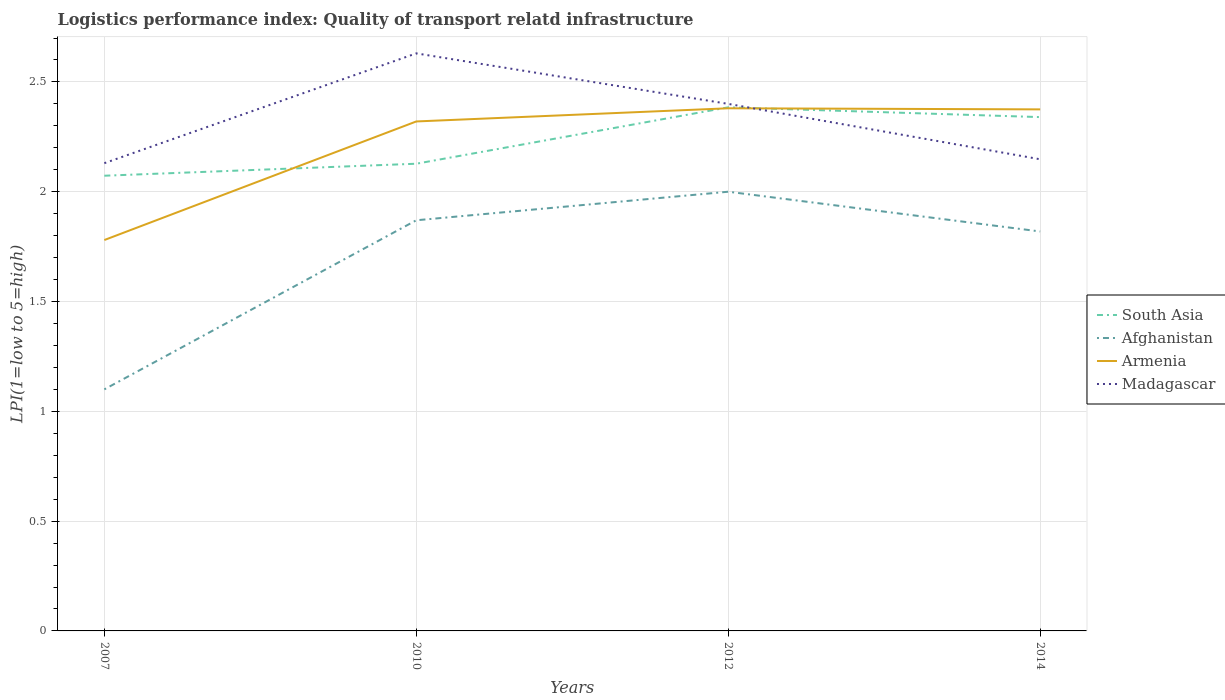Across all years, what is the maximum logistics performance index in Madagascar?
Give a very brief answer. 2.13. What is the total logistics performance index in Afghanistan in the graph?
Offer a terse response. -0.72. What is the difference between the highest and the second highest logistics performance index in Armenia?
Give a very brief answer. 0.6. How many lines are there?
Provide a short and direct response. 4. How many years are there in the graph?
Provide a short and direct response. 4. What is the difference between two consecutive major ticks on the Y-axis?
Your answer should be compact. 0.5. Are the values on the major ticks of Y-axis written in scientific E-notation?
Your answer should be compact. No. Does the graph contain any zero values?
Ensure brevity in your answer.  No. How many legend labels are there?
Give a very brief answer. 4. How are the legend labels stacked?
Offer a terse response. Vertical. What is the title of the graph?
Give a very brief answer. Logistics performance index: Quality of transport relatd infrastructure. What is the label or title of the X-axis?
Ensure brevity in your answer.  Years. What is the label or title of the Y-axis?
Keep it short and to the point. LPI(1=low to 5=high). What is the LPI(1=low to 5=high) of South Asia in 2007?
Give a very brief answer. 2.07. What is the LPI(1=low to 5=high) of Afghanistan in 2007?
Provide a short and direct response. 1.1. What is the LPI(1=low to 5=high) in Armenia in 2007?
Offer a terse response. 1.78. What is the LPI(1=low to 5=high) in Madagascar in 2007?
Your answer should be very brief. 2.13. What is the LPI(1=low to 5=high) of South Asia in 2010?
Offer a very short reply. 2.13. What is the LPI(1=low to 5=high) in Afghanistan in 2010?
Make the answer very short. 1.87. What is the LPI(1=low to 5=high) in Armenia in 2010?
Your answer should be very brief. 2.32. What is the LPI(1=low to 5=high) in Madagascar in 2010?
Provide a succinct answer. 2.63. What is the LPI(1=low to 5=high) of South Asia in 2012?
Your answer should be compact. 2.38. What is the LPI(1=low to 5=high) in Armenia in 2012?
Your answer should be very brief. 2.38. What is the LPI(1=low to 5=high) of Madagascar in 2012?
Provide a short and direct response. 2.4. What is the LPI(1=low to 5=high) of South Asia in 2014?
Your response must be concise. 2.34. What is the LPI(1=low to 5=high) in Afghanistan in 2014?
Your answer should be compact. 1.82. What is the LPI(1=low to 5=high) of Armenia in 2014?
Ensure brevity in your answer.  2.38. What is the LPI(1=low to 5=high) in Madagascar in 2014?
Offer a terse response. 2.15. Across all years, what is the maximum LPI(1=low to 5=high) of South Asia?
Provide a short and direct response. 2.38. Across all years, what is the maximum LPI(1=low to 5=high) of Afghanistan?
Your answer should be very brief. 2. Across all years, what is the maximum LPI(1=low to 5=high) of Armenia?
Your response must be concise. 2.38. Across all years, what is the maximum LPI(1=low to 5=high) of Madagascar?
Provide a short and direct response. 2.63. Across all years, what is the minimum LPI(1=low to 5=high) of South Asia?
Keep it short and to the point. 2.07. Across all years, what is the minimum LPI(1=low to 5=high) of Armenia?
Offer a very short reply. 1.78. Across all years, what is the minimum LPI(1=low to 5=high) of Madagascar?
Give a very brief answer. 2.13. What is the total LPI(1=low to 5=high) of South Asia in the graph?
Give a very brief answer. 8.92. What is the total LPI(1=low to 5=high) of Afghanistan in the graph?
Offer a terse response. 6.79. What is the total LPI(1=low to 5=high) in Armenia in the graph?
Your answer should be compact. 8.86. What is the total LPI(1=low to 5=high) in Madagascar in the graph?
Your answer should be very brief. 9.31. What is the difference between the LPI(1=low to 5=high) of South Asia in 2007 and that in 2010?
Offer a very short reply. -0.05. What is the difference between the LPI(1=low to 5=high) in Afghanistan in 2007 and that in 2010?
Offer a very short reply. -0.77. What is the difference between the LPI(1=low to 5=high) of Armenia in 2007 and that in 2010?
Your answer should be very brief. -0.54. What is the difference between the LPI(1=low to 5=high) of South Asia in 2007 and that in 2012?
Offer a terse response. -0.31. What is the difference between the LPI(1=low to 5=high) in Afghanistan in 2007 and that in 2012?
Offer a terse response. -0.9. What is the difference between the LPI(1=low to 5=high) in Armenia in 2007 and that in 2012?
Your response must be concise. -0.6. What is the difference between the LPI(1=low to 5=high) of Madagascar in 2007 and that in 2012?
Provide a short and direct response. -0.27. What is the difference between the LPI(1=low to 5=high) in South Asia in 2007 and that in 2014?
Your response must be concise. -0.27. What is the difference between the LPI(1=low to 5=high) of Afghanistan in 2007 and that in 2014?
Offer a terse response. -0.72. What is the difference between the LPI(1=low to 5=high) of Armenia in 2007 and that in 2014?
Your answer should be compact. -0.59. What is the difference between the LPI(1=low to 5=high) of Madagascar in 2007 and that in 2014?
Provide a succinct answer. -0.02. What is the difference between the LPI(1=low to 5=high) of South Asia in 2010 and that in 2012?
Provide a succinct answer. -0.26. What is the difference between the LPI(1=low to 5=high) in Afghanistan in 2010 and that in 2012?
Offer a very short reply. -0.13. What is the difference between the LPI(1=low to 5=high) in Armenia in 2010 and that in 2012?
Ensure brevity in your answer.  -0.06. What is the difference between the LPI(1=low to 5=high) in Madagascar in 2010 and that in 2012?
Your answer should be very brief. 0.23. What is the difference between the LPI(1=low to 5=high) of South Asia in 2010 and that in 2014?
Give a very brief answer. -0.21. What is the difference between the LPI(1=low to 5=high) in Afghanistan in 2010 and that in 2014?
Provide a short and direct response. 0.05. What is the difference between the LPI(1=low to 5=high) in Armenia in 2010 and that in 2014?
Your answer should be compact. -0.06. What is the difference between the LPI(1=low to 5=high) of Madagascar in 2010 and that in 2014?
Make the answer very short. 0.48. What is the difference between the LPI(1=low to 5=high) in South Asia in 2012 and that in 2014?
Offer a terse response. 0.04. What is the difference between the LPI(1=low to 5=high) in Afghanistan in 2012 and that in 2014?
Provide a succinct answer. 0.18. What is the difference between the LPI(1=low to 5=high) in Armenia in 2012 and that in 2014?
Ensure brevity in your answer.  0.01. What is the difference between the LPI(1=low to 5=high) in Madagascar in 2012 and that in 2014?
Give a very brief answer. 0.25. What is the difference between the LPI(1=low to 5=high) of South Asia in 2007 and the LPI(1=low to 5=high) of Afghanistan in 2010?
Provide a succinct answer. 0.2. What is the difference between the LPI(1=low to 5=high) in South Asia in 2007 and the LPI(1=low to 5=high) in Armenia in 2010?
Provide a short and direct response. -0.25. What is the difference between the LPI(1=low to 5=high) of South Asia in 2007 and the LPI(1=low to 5=high) of Madagascar in 2010?
Offer a terse response. -0.56. What is the difference between the LPI(1=low to 5=high) of Afghanistan in 2007 and the LPI(1=low to 5=high) of Armenia in 2010?
Keep it short and to the point. -1.22. What is the difference between the LPI(1=low to 5=high) in Afghanistan in 2007 and the LPI(1=low to 5=high) in Madagascar in 2010?
Ensure brevity in your answer.  -1.53. What is the difference between the LPI(1=low to 5=high) of Armenia in 2007 and the LPI(1=low to 5=high) of Madagascar in 2010?
Make the answer very short. -0.85. What is the difference between the LPI(1=low to 5=high) in South Asia in 2007 and the LPI(1=low to 5=high) in Afghanistan in 2012?
Offer a terse response. 0.07. What is the difference between the LPI(1=low to 5=high) in South Asia in 2007 and the LPI(1=low to 5=high) in Armenia in 2012?
Make the answer very short. -0.31. What is the difference between the LPI(1=low to 5=high) in South Asia in 2007 and the LPI(1=low to 5=high) in Madagascar in 2012?
Your response must be concise. -0.33. What is the difference between the LPI(1=low to 5=high) in Afghanistan in 2007 and the LPI(1=low to 5=high) in Armenia in 2012?
Your answer should be very brief. -1.28. What is the difference between the LPI(1=low to 5=high) of Armenia in 2007 and the LPI(1=low to 5=high) of Madagascar in 2012?
Provide a short and direct response. -0.62. What is the difference between the LPI(1=low to 5=high) of South Asia in 2007 and the LPI(1=low to 5=high) of Afghanistan in 2014?
Give a very brief answer. 0.25. What is the difference between the LPI(1=low to 5=high) in South Asia in 2007 and the LPI(1=low to 5=high) in Armenia in 2014?
Offer a very short reply. -0.3. What is the difference between the LPI(1=low to 5=high) of South Asia in 2007 and the LPI(1=low to 5=high) of Madagascar in 2014?
Provide a succinct answer. -0.07. What is the difference between the LPI(1=low to 5=high) in Afghanistan in 2007 and the LPI(1=low to 5=high) in Armenia in 2014?
Offer a terse response. -1.27. What is the difference between the LPI(1=low to 5=high) of Afghanistan in 2007 and the LPI(1=low to 5=high) of Madagascar in 2014?
Provide a short and direct response. -1.05. What is the difference between the LPI(1=low to 5=high) of Armenia in 2007 and the LPI(1=low to 5=high) of Madagascar in 2014?
Your answer should be very brief. -0.37. What is the difference between the LPI(1=low to 5=high) of South Asia in 2010 and the LPI(1=low to 5=high) of Afghanistan in 2012?
Your answer should be very brief. 0.13. What is the difference between the LPI(1=low to 5=high) of South Asia in 2010 and the LPI(1=low to 5=high) of Armenia in 2012?
Keep it short and to the point. -0.25. What is the difference between the LPI(1=low to 5=high) of South Asia in 2010 and the LPI(1=low to 5=high) of Madagascar in 2012?
Your response must be concise. -0.27. What is the difference between the LPI(1=low to 5=high) of Afghanistan in 2010 and the LPI(1=low to 5=high) of Armenia in 2012?
Keep it short and to the point. -0.51. What is the difference between the LPI(1=low to 5=high) of Afghanistan in 2010 and the LPI(1=low to 5=high) of Madagascar in 2012?
Your answer should be compact. -0.53. What is the difference between the LPI(1=low to 5=high) of Armenia in 2010 and the LPI(1=low to 5=high) of Madagascar in 2012?
Provide a succinct answer. -0.08. What is the difference between the LPI(1=low to 5=high) of South Asia in 2010 and the LPI(1=low to 5=high) of Afghanistan in 2014?
Provide a short and direct response. 0.31. What is the difference between the LPI(1=low to 5=high) in South Asia in 2010 and the LPI(1=low to 5=high) in Armenia in 2014?
Your response must be concise. -0.25. What is the difference between the LPI(1=low to 5=high) of South Asia in 2010 and the LPI(1=low to 5=high) of Madagascar in 2014?
Keep it short and to the point. -0.02. What is the difference between the LPI(1=low to 5=high) of Afghanistan in 2010 and the LPI(1=low to 5=high) of Armenia in 2014?
Your answer should be compact. -0.51. What is the difference between the LPI(1=low to 5=high) of Afghanistan in 2010 and the LPI(1=low to 5=high) of Madagascar in 2014?
Keep it short and to the point. -0.28. What is the difference between the LPI(1=low to 5=high) of Armenia in 2010 and the LPI(1=low to 5=high) of Madagascar in 2014?
Provide a succinct answer. 0.17. What is the difference between the LPI(1=low to 5=high) of South Asia in 2012 and the LPI(1=low to 5=high) of Afghanistan in 2014?
Your answer should be very brief. 0.57. What is the difference between the LPI(1=low to 5=high) of South Asia in 2012 and the LPI(1=low to 5=high) of Armenia in 2014?
Offer a terse response. 0.01. What is the difference between the LPI(1=low to 5=high) in South Asia in 2012 and the LPI(1=low to 5=high) in Madagascar in 2014?
Keep it short and to the point. 0.24. What is the difference between the LPI(1=low to 5=high) in Afghanistan in 2012 and the LPI(1=low to 5=high) in Armenia in 2014?
Make the answer very short. -0.38. What is the difference between the LPI(1=low to 5=high) in Afghanistan in 2012 and the LPI(1=low to 5=high) in Madagascar in 2014?
Provide a succinct answer. -0.15. What is the difference between the LPI(1=low to 5=high) in Armenia in 2012 and the LPI(1=low to 5=high) in Madagascar in 2014?
Provide a succinct answer. 0.23. What is the average LPI(1=low to 5=high) of South Asia per year?
Offer a terse response. 2.23. What is the average LPI(1=low to 5=high) in Afghanistan per year?
Provide a succinct answer. 1.7. What is the average LPI(1=low to 5=high) of Armenia per year?
Your response must be concise. 2.21. What is the average LPI(1=low to 5=high) of Madagascar per year?
Provide a succinct answer. 2.33. In the year 2007, what is the difference between the LPI(1=low to 5=high) in South Asia and LPI(1=low to 5=high) in Afghanistan?
Give a very brief answer. 0.97. In the year 2007, what is the difference between the LPI(1=low to 5=high) of South Asia and LPI(1=low to 5=high) of Armenia?
Provide a succinct answer. 0.29. In the year 2007, what is the difference between the LPI(1=low to 5=high) of South Asia and LPI(1=low to 5=high) of Madagascar?
Offer a terse response. -0.06. In the year 2007, what is the difference between the LPI(1=low to 5=high) of Afghanistan and LPI(1=low to 5=high) of Armenia?
Offer a very short reply. -0.68. In the year 2007, what is the difference between the LPI(1=low to 5=high) of Afghanistan and LPI(1=low to 5=high) of Madagascar?
Give a very brief answer. -1.03. In the year 2007, what is the difference between the LPI(1=low to 5=high) of Armenia and LPI(1=low to 5=high) of Madagascar?
Offer a very short reply. -0.35. In the year 2010, what is the difference between the LPI(1=low to 5=high) in South Asia and LPI(1=low to 5=high) in Afghanistan?
Offer a very short reply. 0.26. In the year 2010, what is the difference between the LPI(1=low to 5=high) in South Asia and LPI(1=low to 5=high) in Armenia?
Give a very brief answer. -0.19. In the year 2010, what is the difference between the LPI(1=low to 5=high) of South Asia and LPI(1=low to 5=high) of Madagascar?
Your answer should be compact. -0.5. In the year 2010, what is the difference between the LPI(1=low to 5=high) in Afghanistan and LPI(1=low to 5=high) in Armenia?
Offer a terse response. -0.45. In the year 2010, what is the difference between the LPI(1=low to 5=high) of Afghanistan and LPI(1=low to 5=high) of Madagascar?
Give a very brief answer. -0.76. In the year 2010, what is the difference between the LPI(1=low to 5=high) of Armenia and LPI(1=low to 5=high) of Madagascar?
Provide a succinct answer. -0.31. In the year 2012, what is the difference between the LPI(1=low to 5=high) in South Asia and LPI(1=low to 5=high) in Afghanistan?
Give a very brief answer. 0.38. In the year 2012, what is the difference between the LPI(1=low to 5=high) of South Asia and LPI(1=low to 5=high) of Armenia?
Your response must be concise. 0. In the year 2012, what is the difference between the LPI(1=low to 5=high) of South Asia and LPI(1=low to 5=high) of Madagascar?
Give a very brief answer. -0.02. In the year 2012, what is the difference between the LPI(1=low to 5=high) of Afghanistan and LPI(1=low to 5=high) of Armenia?
Provide a short and direct response. -0.38. In the year 2012, what is the difference between the LPI(1=low to 5=high) of Afghanistan and LPI(1=low to 5=high) of Madagascar?
Ensure brevity in your answer.  -0.4. In the year 2012, what is the difference between the LPI(1=low to 5=high) of Armenia and LPI(1=low to 5=high) of Madagascar?
Provide a succinct answer. -0.02. In the year 2014, what is the difference between the LPI(1=low to 5=high) in South Asia and LPI(1=low to 5=high) in Afghanistan?
Offer a very short reply. 0.52. In the year 2014, what is the difference between the LPI(1=low to 5=high) of South Asia and LPI(1=low to 5=high) of Armenia?
Ensure brevity in your answer.  -0.04. In the year 2014, what is the difference between the LPI(1=low to 5=high) of South Asia and LPI(1=low to 5=high) of Madagascar?
Offer a very short reply. 0.19. In the year 2014, what is the difference between the LPI(1=low to 5=high) of Afghanistan and LPI(1=low to 5=high) of Armenia?
Provide a succinct answer. -0.56. In the year 2014, what is the difference between the LPI(1=low to 5=high) in Afghanistan and LPI(1=low to 5=high) in Madagascar?
Offer a very short reply. -0.33. In the year 2014, what is the difference between the LPI(1=low to 5=high) in Armenia and LPI(1=low to 5=high) in Madagascar?
Your answer should be very brief. 0.23. What is the ratio of the LPI(1=low to 5=high) in South Asia in 2007 to that in 2010?
Keep it short and to the point. 0.97. What is the ratio of the LPI(1=low to 5=high) of Afghanistan in 2007 to that in 2010?
Make the answer very short. 0.59. What is the ratio of the LPI(1=low to 5=high) in Armenia in 2007 to that in 2010?
Provide a succinct answer. 0.77. What is the ratio of the LPI(1=low to 5=high) in Madagascar in 2007 to that in 2010?
Your response must be concise. 0.81. What is the ratio of the LPI(1=low to 5=high) of South Asia in 2007 to that in 2012?
Your answer should be compact. 0.87. What is the ratio of the LPI(1=low to 5=high) in Afghanistan in 2007 to that in 2012?
Provide a short and direct response. 0.55. What is the ratio of the LPI(1=low to 5=high) in Armenia in 2007 to that in 2012?
Offer a very short reply. 0.75. What is the ratio of the LPI(1=low to 5=high) in Madagascar in 2007 to that in 2012?
Make the answer very short. 0.89. What is the ratio of the LPI(1=low to 5=high) of South Asia in 2007 to that in 2014?
Offer a terse response. 0.89. What is the ratio of the LPI(1=low to 5=high) of Afghanistan in 2007 to that in 2014?
Offer a terse response. 0.6. What is the ratio of the LPI(1=low to 5=high) of Armenia in 2007 to that in 2014?
Your response must be concise. 0.75. What is the ratio of the LPI(1=low to 5=high) in South Asia in 2010 to that in 2012?
Offer a very short reply. 0.89. What is the ratio of the LPI(1=low to 5=high) in Afghanistan in 2010 to that in 2012?
Give a very brief answer. 0.94. What is the ratio of the LPI(1=low to 5=high) in Armenia in 2010 to that in 2012?
Your response must be concise. 0.97. What is the ratio of the LPI(1=low to 5=high) in Madagascar in 2010 to that in 2012?
Your answer should be very brief. 1.1. What is the ratio of the LPI(1=low to 5=high) of South Asia in 2010 to that in 2014?
Your answer should be very brief. 0.91. What is the ratio of the LPI(1=low to 5=high) of Afghanistan in 2010 to that in 2014?
Your answer should be compact. 1.03. What is the ratio of the LPI(1=low to 5=high) in Armenia in 2010 to that in 2014?
Offer a very short reply. 0.98. What is the ratio of the LPI(1=low to 5=high) of Madagascar in 2010 to that in 2014?
Your answer should be very brief. 1.22. What is the ratio of the LPI(1=low to 5=high) of Afghanistan in 2012 to that in 2014?
Give a very brief answer. 1.1. What is the ratio of the LPI(1=low to 5=high) of Madagascar in 2012 to that in 2014?
Ensure brevity in your answer.  1.12. What is the difference between the highest and the second highest LPI(1=low to 5=high) of South Asia?
Your response must be concise. 0.04. What is the difference between the highest and the second highest LPI(1=low to 5=high) of Afghanistan?
Provide a succinct answer. 0.13. What is the difference between the highest and the second highest LPI(1=low to 5=high) of Armenia?
Offer a terse response. 0.01. What is the difference between the highest and the second highest LPI(1=low to 5=high) of Madagascar?
Give a very brief answer. 0.23. What is the difference between the highest and the lowest LPI(1=low to 5=high) of South Asia?
Your response must be concise. 0.31. What is the difference between the highest and the lowest LPI(1=low to 5=high) in Afghanistan?
Make the answer very short. 0.9. What is the difference between the highest and the lowest LPI(1=low to 5=high) in Madagascar?
Make the answer very short. 0.5. 